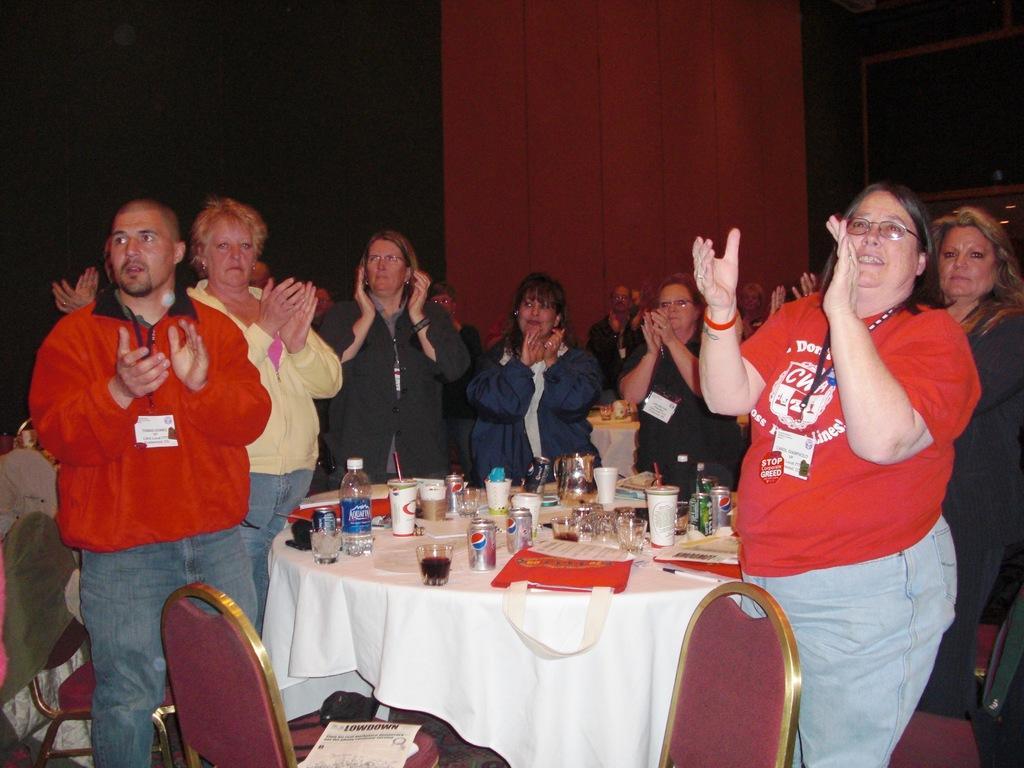In one or two sentences, can you explain what this image depicts? This is the picture of a group of people standing around the table on which there are some bottles, cups, glasses and notes and behind that is red color cotton to the wall and there some chairs. 